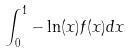<formula> <loc_0><loc_0><loc_500><loc_500>\int _ { 0 } ^ { 1 } - \ln ( x ) f ( x ) d x</formula> 